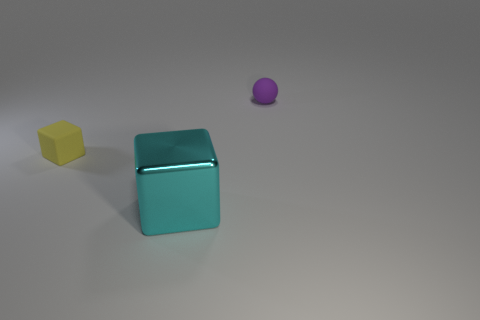There is a ball that is behind the small rubber cube; what is its size?
Offer a very short reply. Small. Do the tiny yellow cube and the large object that is right of the yellow matte object have the same material?
Your answer should be very brief. No. There is a yellow cube to the left of the matte object that is behind the tiny yellow block; how many tiny purple rubber things are on the right side of it?
Keep it short and to the point. 1. How many brown objects are either big spheres or large shiny things?
Your response must be concise. 0. What shape is the rubber thing that is right of the small cube?
Offer a very short reply. Sphere. The matte block that is the same size as the purple thing is what color?
Your answer should be compact. Yellow. There is a cyan object; does it have the same shape as the tiny rubber thing that is on the left side of the large metal block?
Ensure brevity in your answer.  Yes. There is a cyan thing that is right of the small rubber object on the left side of the tiny thing that is to the right of the tiny yellow object; what is its material?
Your response must be concise. Metal. What number of big things are yellow blocks or cyan rubber cylinders?
Give a very brief answer. 0. What number of other things are the same size as the metallic block?
Your answer should be very brief. 0. 